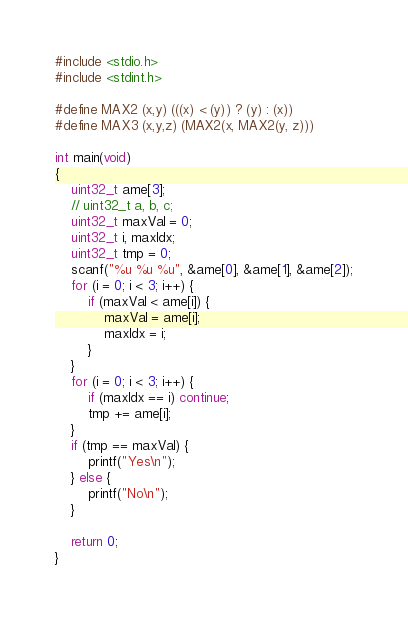Convert code to text. <code><loc_0><loc_0><loc_500><loc_500><_C_>#include <stdio.h>
#include <stdint.h>

#define MAX2 (x,y) (((x) < (y)) ? (y) : (x))
#define MAX3 (x,y,z) (MAX2(x, MAX2(y, z)))

int main(void)
{
    uint32_t ame[3];
    // uint32_t a, b, c;
    uint32_t maxVal = 0;
    uint32_t i, maxIdx;
    uint32_t tmp = 0;
    scanf("%u %u %u", &ame[0], &ame[1], &ame[2]);
    for (i = 0; i < 3; i++) {
        if (maxVal < ame[i]) {
            maxVal = ame[i];
            maxIdx = i;
        }
    }
    for (i = 0; i < 3; i++) {
        if (maxIdx == i) continue;
        tmp += ame[i];
    }
    if (tmp == maxVal) {
        printf("Yes\n");
    } else {
        printf("No\n");
    }

    return 0;
}
</code> 